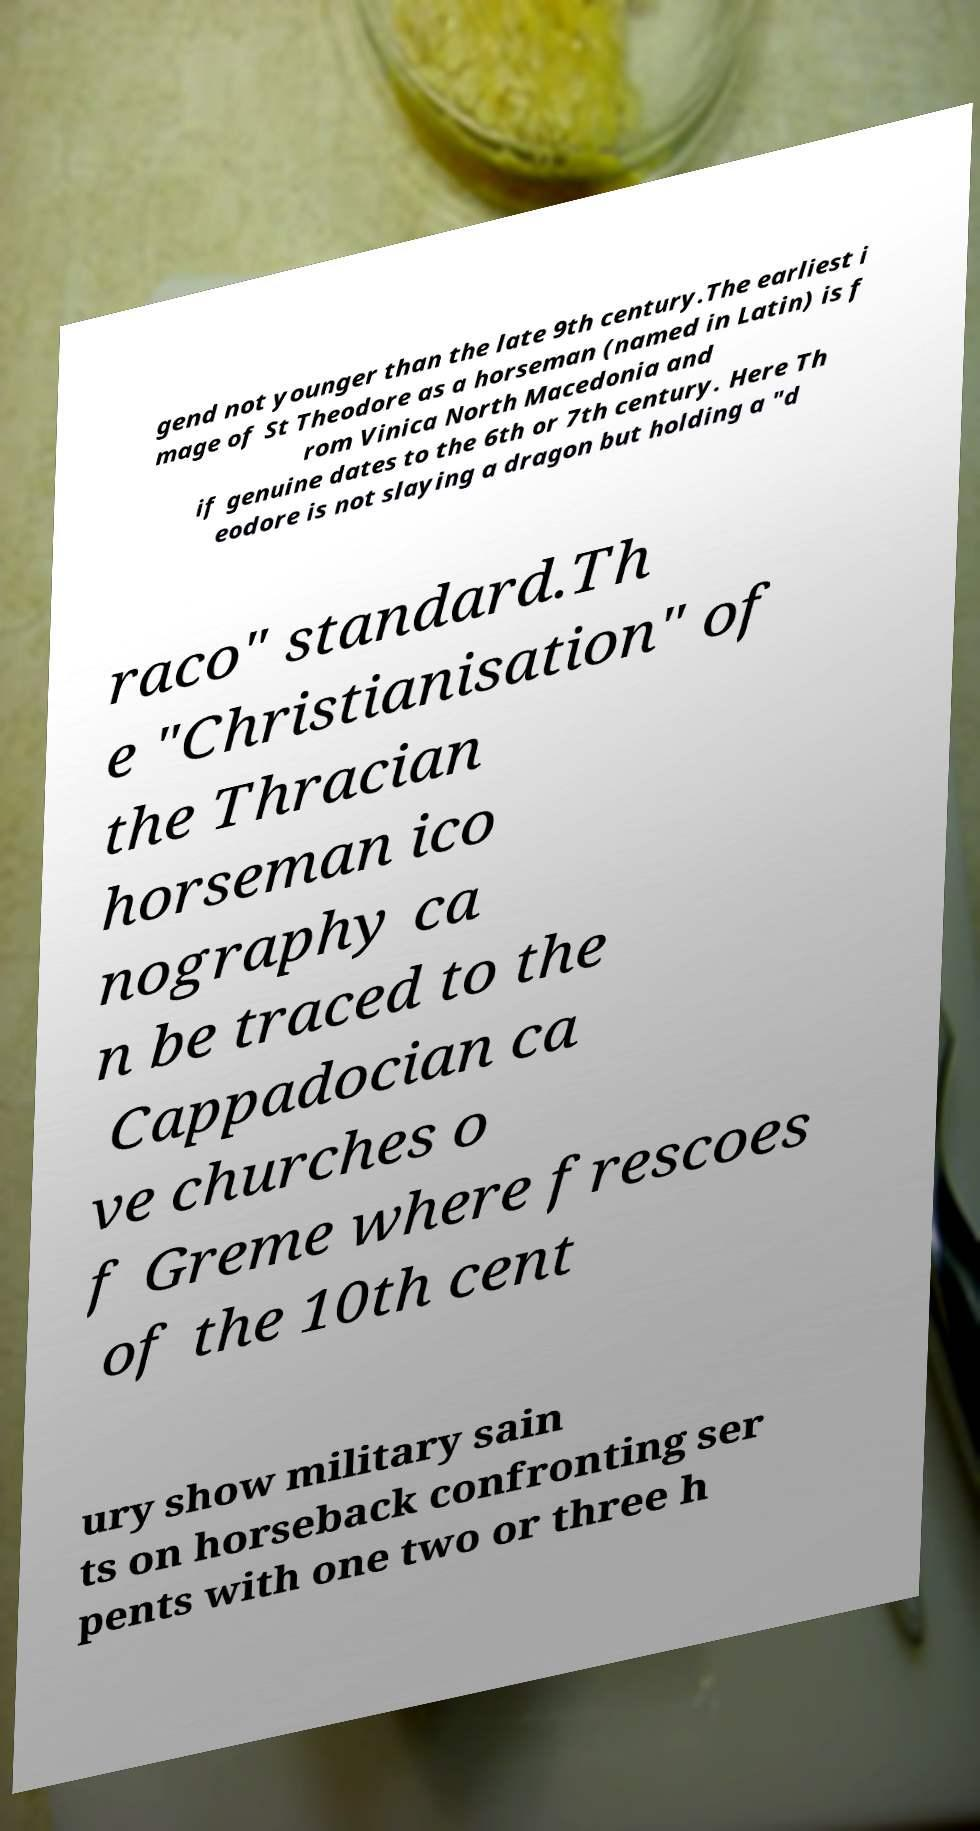What messages or text are displayed in this image? I need them in a readable, typed format. gend not younger than the late 9th century.The earliest i mage of St Theodore as a horseman (named in Latin) is f rom Vinica North Macedonia and if genuine dates to the 6th or 7th century. Here Th eodore is not slaying a dragon but holding a "d raco" standard.Th e "Christianisation" of the Thracian horseman ico nography ca n be traced to the Cappadocian ca ve churches o f Greme where frescoes of the 10th cent ury show military sain ts on horseback confronting ser pents with one two or three h 